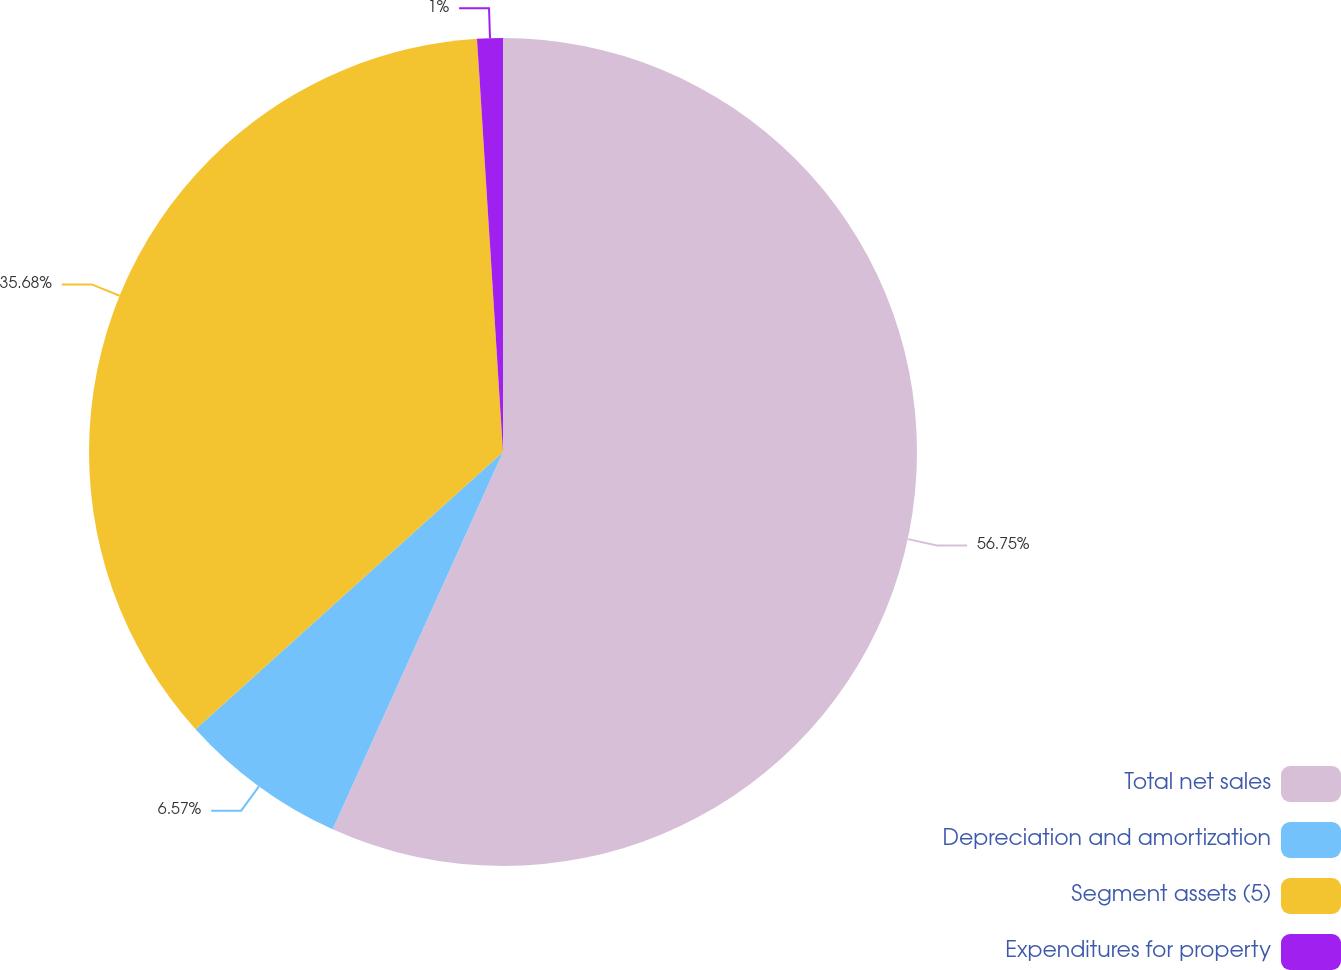Convert chart to OTSL. <chart><loc_0><loc_0><loc_500><loc_500><pie_chart><fcel>Total net sales<fcel>Depreciation and amortization<fcel>Segment assets (5)<fcel>Expenditures for property<nl><fcel>56.75%<fcel>6.57%<fcel>35.68%<fcel>1.0%<nl></chart> 